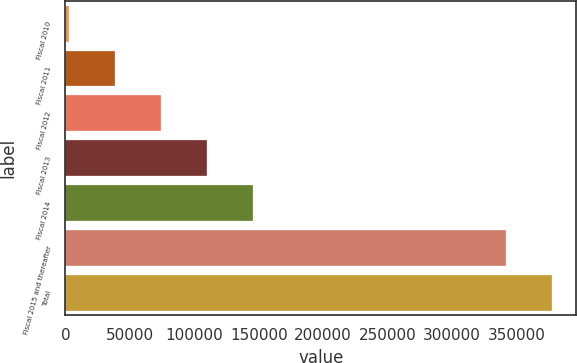<chart> <loc_0><loc_0><loc_500><loc_500><bar_chart><fcel>Fiscal 2010<fcel>Fiscal 2011<fcel>Fiscal 2012<fcel>Fiscal 2013<fcel>Fiscal 2014<fcel>Fiscal 2015 and thereafter<fcel>Total<nl><fcel>3075<fcel>38670.9<fcel>74266.8<fcel>109863<fcel>145459<fcel>341752<fcel>377348<nl></chart> 